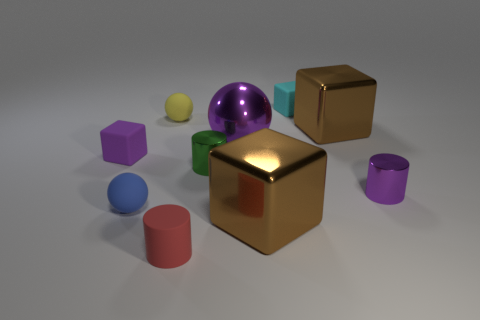What is the material of the yellow object?
Offer a very short reply. Rubber. What number of rubber spheres are the same size as the purple shiny sphere?
Keep it short and to the point. 0. The tiny metal object that is the same color as the big ball is what shape?
Ensure brevity in your answer.  Cylinder. Is there a yellow matte thing that has the same shape as the tiny green object?
Offer a very short reply. No. What color is the rubber cube that is the same size as the cyan matte object?
Offer a very short reply. Purple. What is the color of the large metal block to the right of the large brown shiny thing that is in front of the big shiny sphere?
Make the answer very short. Brown. Is the color of the large object that is behind the metal sphere the same as the large metallic ball?
Make the answer very short. No. What shape is the big object that is right of the small matte cube that is on the right side of the small red matte cylinder that is in front of the purple sphere?
Your response must be concise. Cube. There is a big metallic block behind the tiny blue rubber object; what number of small metal objects are right of it?
Ensure brevity in your answer.  1. Do the red object and the cyan cube have the same material?
Your answer should be compact. Yes. 